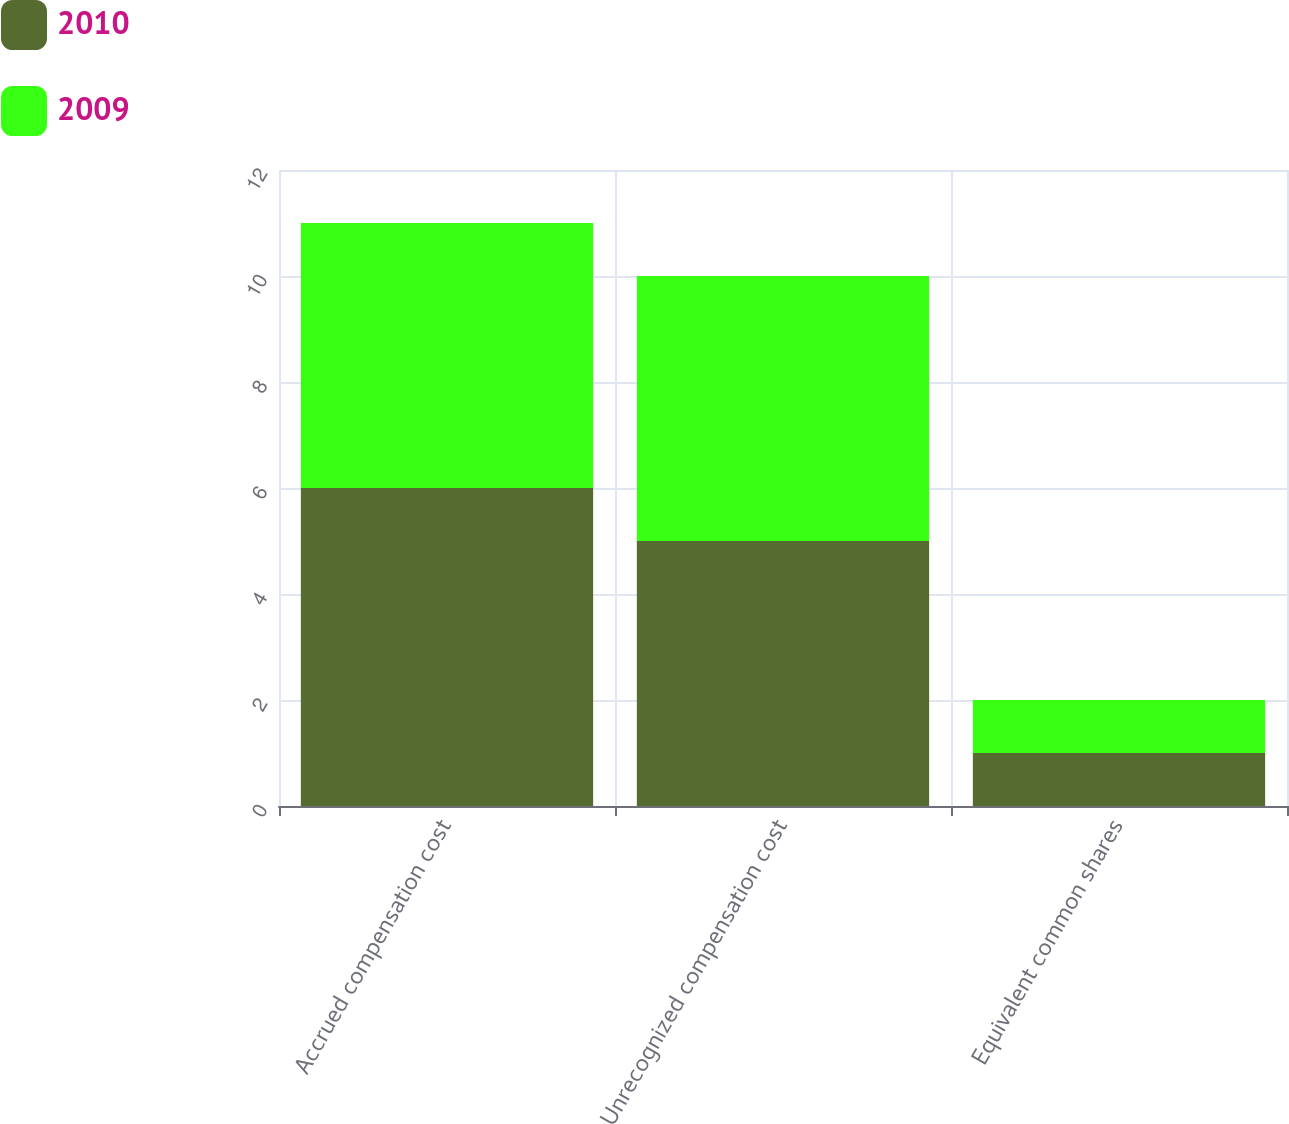Convert chart to OTSL. <chart><loc_0><loc_0><loc_500><loc_500><stacked_bar_chart><ecel><fcel>Accrued compensation cost<fcel>Unrecognized compensation cost<fcel>Equivalent common shares<nl><fcel>2010<fcel>6<fcel>5<fcel>1<nl><fcel>2009<fcel>5<fcel>5<fcel>1<nl></chart> 